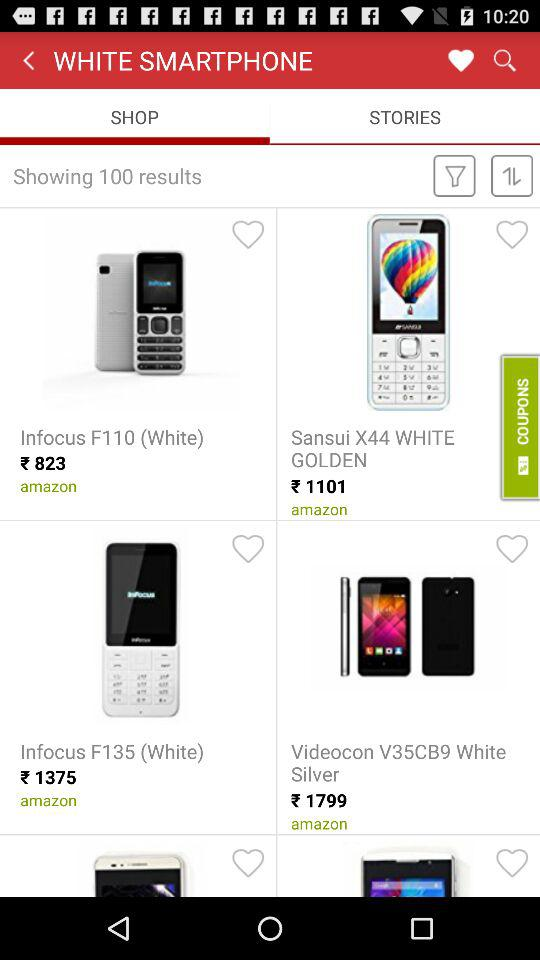How much do I have to pay to buy an "Infocus F135" phone? You have to pay 1375 rupees to buy an "Infocus F135" phone. 